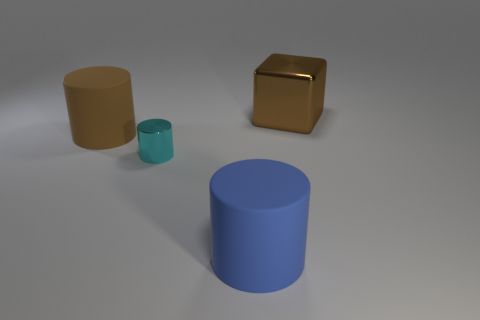Is the small cyan thing made of the same material as the large brown object to the left of the small cyan thing?
Provide a short and direct response. No. There is a thing that is the same color as the metal block; what is its material?
Your answer should be very brief. Rubber. Is the shape of the blue thing the same as the thing that is to the left of the small cyan cylinder?
Give a very brief answer. Yes. There is another large cylinder that is made of the same material as the big blue cylinder; what color is it?
Provide a short and direct response. Brown. How big is the rubber thing behind the blue rubber thing?
Offer a terse response. Large. There is a thing that is right of the big blue rubber cylinder left of the big brown metallic cube; what color is it?
Provide a short and direct response. Brown. There is a large brown object left of the big brown object right of the object that is left of the shiny cylinder; what is it made of?
Keep it short and to the point. Rubber. There is a rubber cylinder left of the metal cylinder; is it the same size as the large brown metallic block?
Provide a short and direct response. Yes. What is the material of the brown thing right of the big brown rubber cylinder?
Ensure brevity in your answer.  Metal. What number of blue things are on the left side of the metallic object that is on the left side of the big cube?
Your response must be concise. 0. 